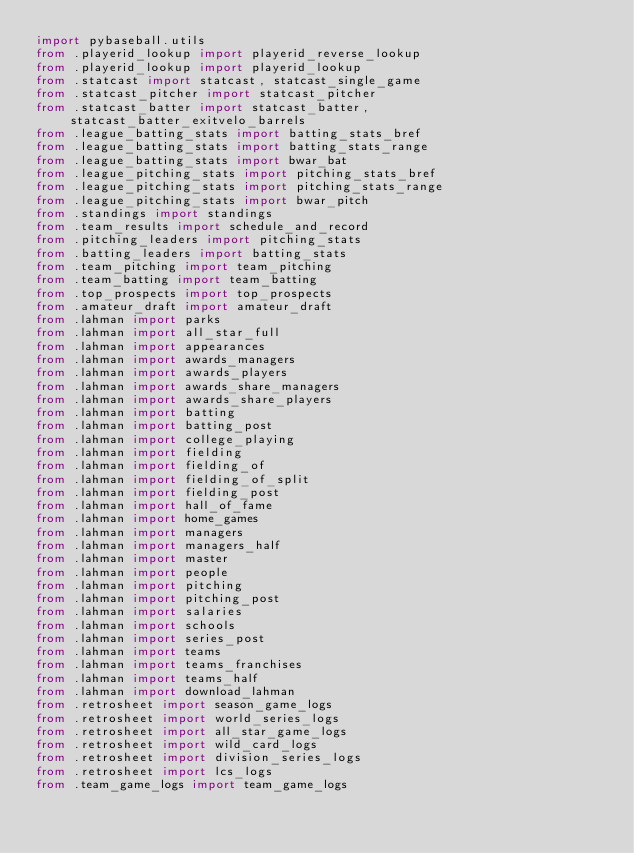Convert code to text. <code><loc_0><loc_0><loc_500><loc_500><_Python_>import pybaseball.utils
from .playerid_lookup import playerid_reverse_lookup
from .playerid_lookup import playerid_lookup
from .statcast import statcast, statcast_single_game
from .statcast_pitcher import statcast_pitcher
from .statcast_batter import statcast_batter, statcast_batter_exitvelo_barrels
from .league_batting_stats import batting_stats_bref
from .league_batting_stats import batting_stats_range
from .league_batting_stats import bwar_bat
from .league_pitching_stats import pitching_stats_bref
from .league_pitching_stats import pitching_stats_range
from .league_pitching_stats import bwar_pitch
from .standings import standings
from .team_results import schedule_and_record
from .pitching_leaders import pitching_stats
from .batting_leaders import batting_stats
from .team_pitching import team_pitching
from .team_batting import team_batting
from .top_prospects import top_prospects
from .amateur_draft import amateur_draft
from .lahman import parks
from .lahman import all_star_full
from .lahman import appearances
from .lahman import awards_managers
from .lahman import awards_players
from .lahman import awards_share_managers
from .lahman import awards_share_players
from .lahman import batting
from .lahman import batting_post
from .lahman import college_playing
from .lahman import fielding
from .lahman import fielding_of
from .lahman import fielding_of_split
from .lahman import fielding_post
from .lahman import hall_of_fame
from .lahman import home_games
from .lahman import managers
from .lahman import managers_half
from .lahman import master
from .lahman import people
from .lahman import pitching
from .lahman import pitching_post
from .lahman import salaries
from .lahman import schools
from .lahman import series_post
from .lahman import teams
from .lahman import teams_franchises
from .lahman import teams_half
from .lahman import download_lahman
from .retrosheet import season_game_logs
from .retrosheet import world_series_logs
from .retrosheet import all_star_game_logs
from .retrosheet import wild_card_logs
from .retrosheet import division_series_logs
from .retrosheet import lcs_logs
from .team_game_logs import team_game_logs
</code> 